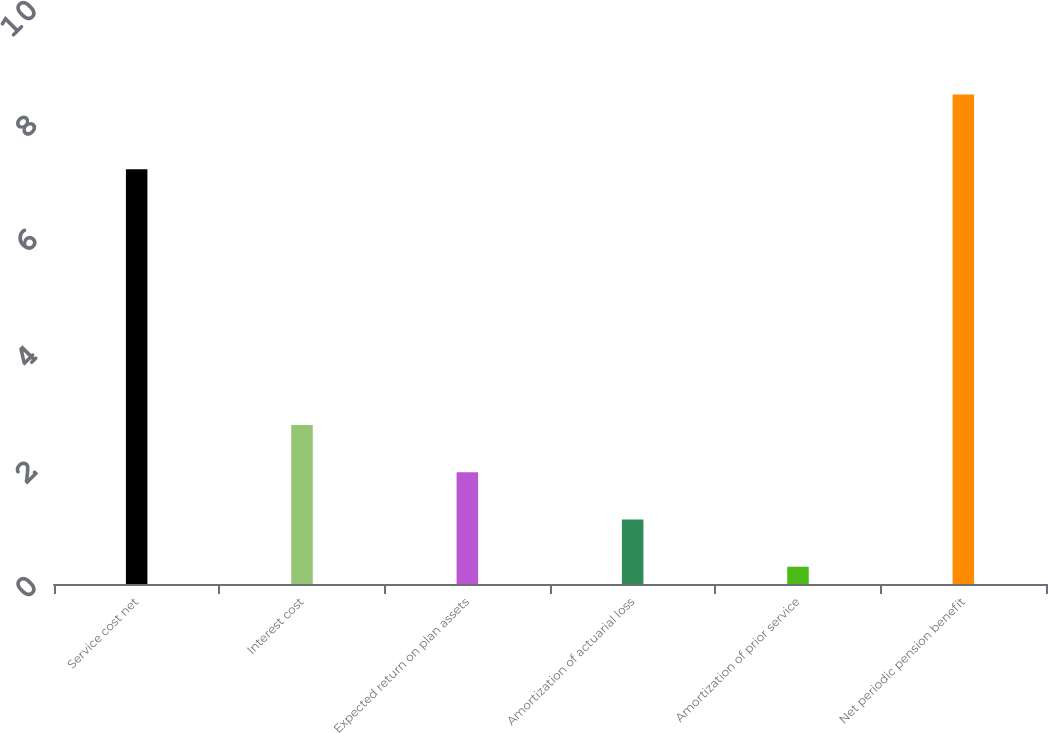Convert chart to OTSL. <chart><loc_0><loc_0><loc_500><loc_500><bar_chart><fcel>Service cost net<fcel>Interest cost<fcel>Expected return on plan assets<fcel>Amortization of actuarial loss<fcel>Amortization of prior service<fcel>Net periodic pension benefit<nl><fcel>7.2<fcel>2.76<fcel>1.94<fcel>1.12<fcel>0.3<fcel>8.5<nl></chart> 